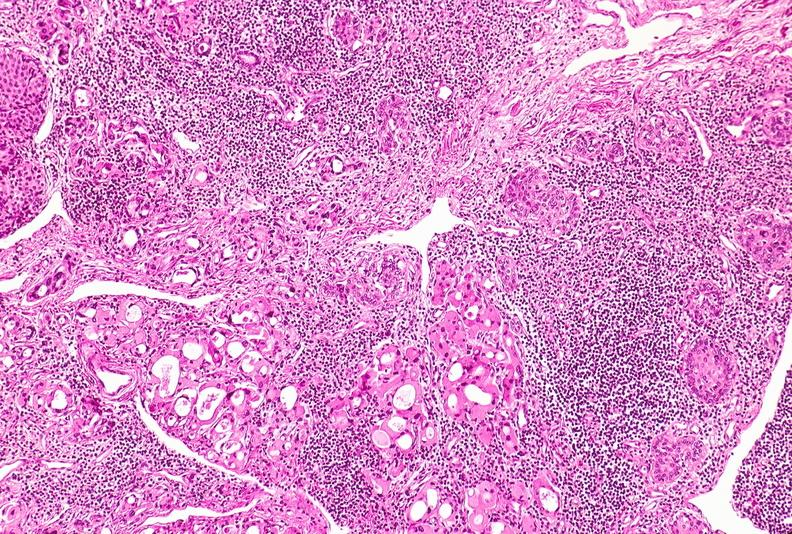does atrophy show thyroid, hashimoto 's?
Answer the question using a single word or phrase. No 